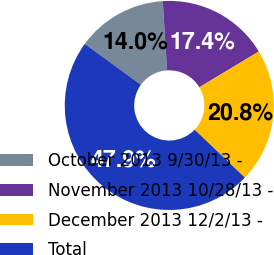Convert chart to OTSL. <chart><loc_0><loc_0><loc_500><loc_500><pie_chart><fcel>October 2013 9/30/13 -<fcel>November 2013 10/28/13 -<fcel>December 2013 12/2/13 -<fcel>Total<nl><fcel>13.98%<fcel>17.37%<fcel>20.76%<fcel>47.89%<nl></chart> 